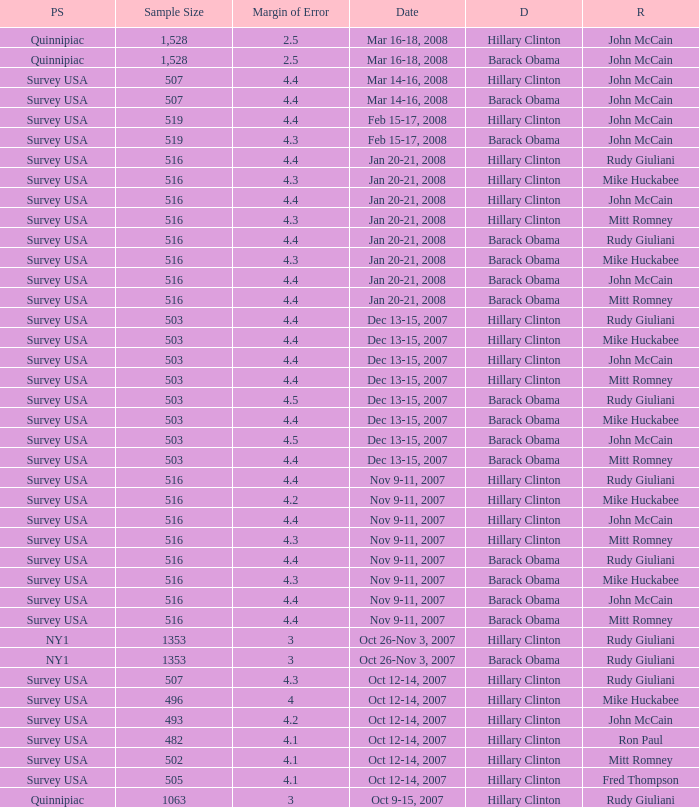Would you mind parsing the complete table? {'header': ['PS', 'Sample Size', 'Margin of Error', 'Date', 'D', 'R'], 'rows': [['Quinnipiac', '1,528', '2.5', 'Mar 16-18, 2008', 'Hillary Clinton', 'John McCain'], ['Quinnipiac', '1,528', '2.5', 'Mar 16-18, 2008', 'Barack Obama', 'John McCain'], ['Survey USA', '507', '4.4', 'Mar 14-16, 2008', 'Hillary Clinton', 'John McCain'], ['Survey USA', '507', '4.4', 'Mar 14-16, 2008', 'Barack Obama', 'John McCain'], ['Survey USA', '519', '4.4', 'Feb 15-17, 2008', 'Hillary Clinton', 'John McCain'], ['Survey USA', '519', '4.3', 'Feb 15-17, 2008', 'Barack Obama', 'John McCain'], ['Survey USA', '516', '4.4', 'Jan 20-21, 2008', 'Hillary Clinton', 'Rudy Giuliani'], ['Survey USA', '516', '4.3', 'Jan 20-21, 2008', 'Hillary Clinton', 'Mike Huckabee'], ['Survey USA', '516', '4.4', 'Jan 20-21, 2008', 'Hillary Clinton', 'John McCain'], ['Survey USA', '516', '4.3', 'Jan 20-21, 2008', 'Hillary Clinton', 'Mitt Romney'], ['Survey USA', '516', '4.4', 'Jan 20-21, 2008', 'Barack Obama', 'Rudy Giuliani'], ['Survey USA', '516', '4.3', 'Jan 20-21, 2008', 'Barack Obama', 'Mike Huckabee'], ['Survey USA', '516', '4.4', 'Jan 20-21, 2008', 'Barack Obama', 'John McCain'], ['Survey USA', '516', '4.4', 'Jan 20-21, 2008', 'Barack Obama', 'Mitt Romney'], ['Survey USA', '503', '4.4', 'Dec 13-15, 2007', 'Hillary Clinton', 'Rudy Giuliani'], ['Survey USA', '503', '4.4', 'Dec 13-15, 2007', 'Hillary Clinton', 'Mike Huckabee'], ['Survey USA', '503', '4.4', 'Dec 13-15, 2007', 'Hillary Clinton', 'John McCain'], ['Survey USA', '503', '4.4', 'Dec 13-15, 2007', 'Hillary Clinton', 'Mitt Romney'], ['Survey USA', '503', '4.5', 'Dec 13-15, 2007', 'Barack Obama', 'Rudy Giuliani'], ['Survey USA', '503', '4.4', 'Dec 13-15, 2007', 'Barack Obama', 'Mike Huckabee'], ['Survey USA', '503', '4.5', 'Dec 13-15, 2007', 'Barack Obama', 'John McCain'], ['Survey USA', '503', '4.4', 'Dec 13-15, 2007', 'Barack Obama', 'Mitt Romney'], ['Survey USA', '516', '4.4', 'Nov 9-11, 2007', 'Hillary Clinton', 'Rudy Giuliani'], ['Survey USA', '516', '4.2', 'Nov 9-11, 2007', 'Hillary Clinton', 'Mike Huckabee'], ['Survey USA', '516', '4.4', 'Nov 9-11, 2007', 'Hillary Clinton', 'John McCain'], ['Survey USA', '516', '4.3', 'Nov 9-11, 2007', 'Hillary Clinton', 'Mitt Romney'], ['Survey USA', '516', '4.4', 'Nov 9-11, 2007', 'Barack Obama', 'Rudy Giuliani'], ['Survey USA', '516', '4.3', 'Nov 9-11, 2007', 'Barack Obama', 'Mike Huckabee'], ['Survey USA', '516', '4.4', 'Nov 9-11, 2007', 'Barack Obama', 'John McCain'], ['Survey USA', '516', '4.4', 'Nov 9-11, 2007', 'Barack Obama', 'Mitt Romney'], ['NY1', '1353', '3', 'Oct 26-Nov 3, 2007', 'Hillary Clinton', 'Rudy Giuliani'], ['NY1', '1353', '3', 'Oct 26-Nov 3, 2007', 'Barack Obama', 'Rudy Giuliani'], ['Survey USA', '507', '4.3', 'Oct 12-14, 2007', 'Hillary Clinton', 'Rudy Giuliani'], ['Survey USA', '496', '4', 'Oct 12-14, 2007', 'Hillary Clinton', 'Mike Huckabee'], ['Survey USA', '493', '4.2', 'Oct 12-14, 2007', 'Hillary Clinton', 'John McCain'], ['Survey USA', '482', '4.1', 'Oct 12-14, 2007', 'Hillary Clinton', 'Ron Paul'], ['Survey USA', '502', '4.1', 'Oct 12-14, 2007', 'Hillary Clinton', 'Mitt Romney'], ['Survey USA', '505', '4.1', 'Oct 12-14, 2007', 'Hillary Clinton', 'Fred Thompson'], ['Quinnipiac', '1063', '3', 'Oct 9-15, 2007', 'Hillary Clinton', 'Rudy Giuliani']]} What is the sample size of the survey conducted on dec 13-15, 2007 that had a margin of error exceeding 4 and ended with republican mike huckabee? 503.0. 